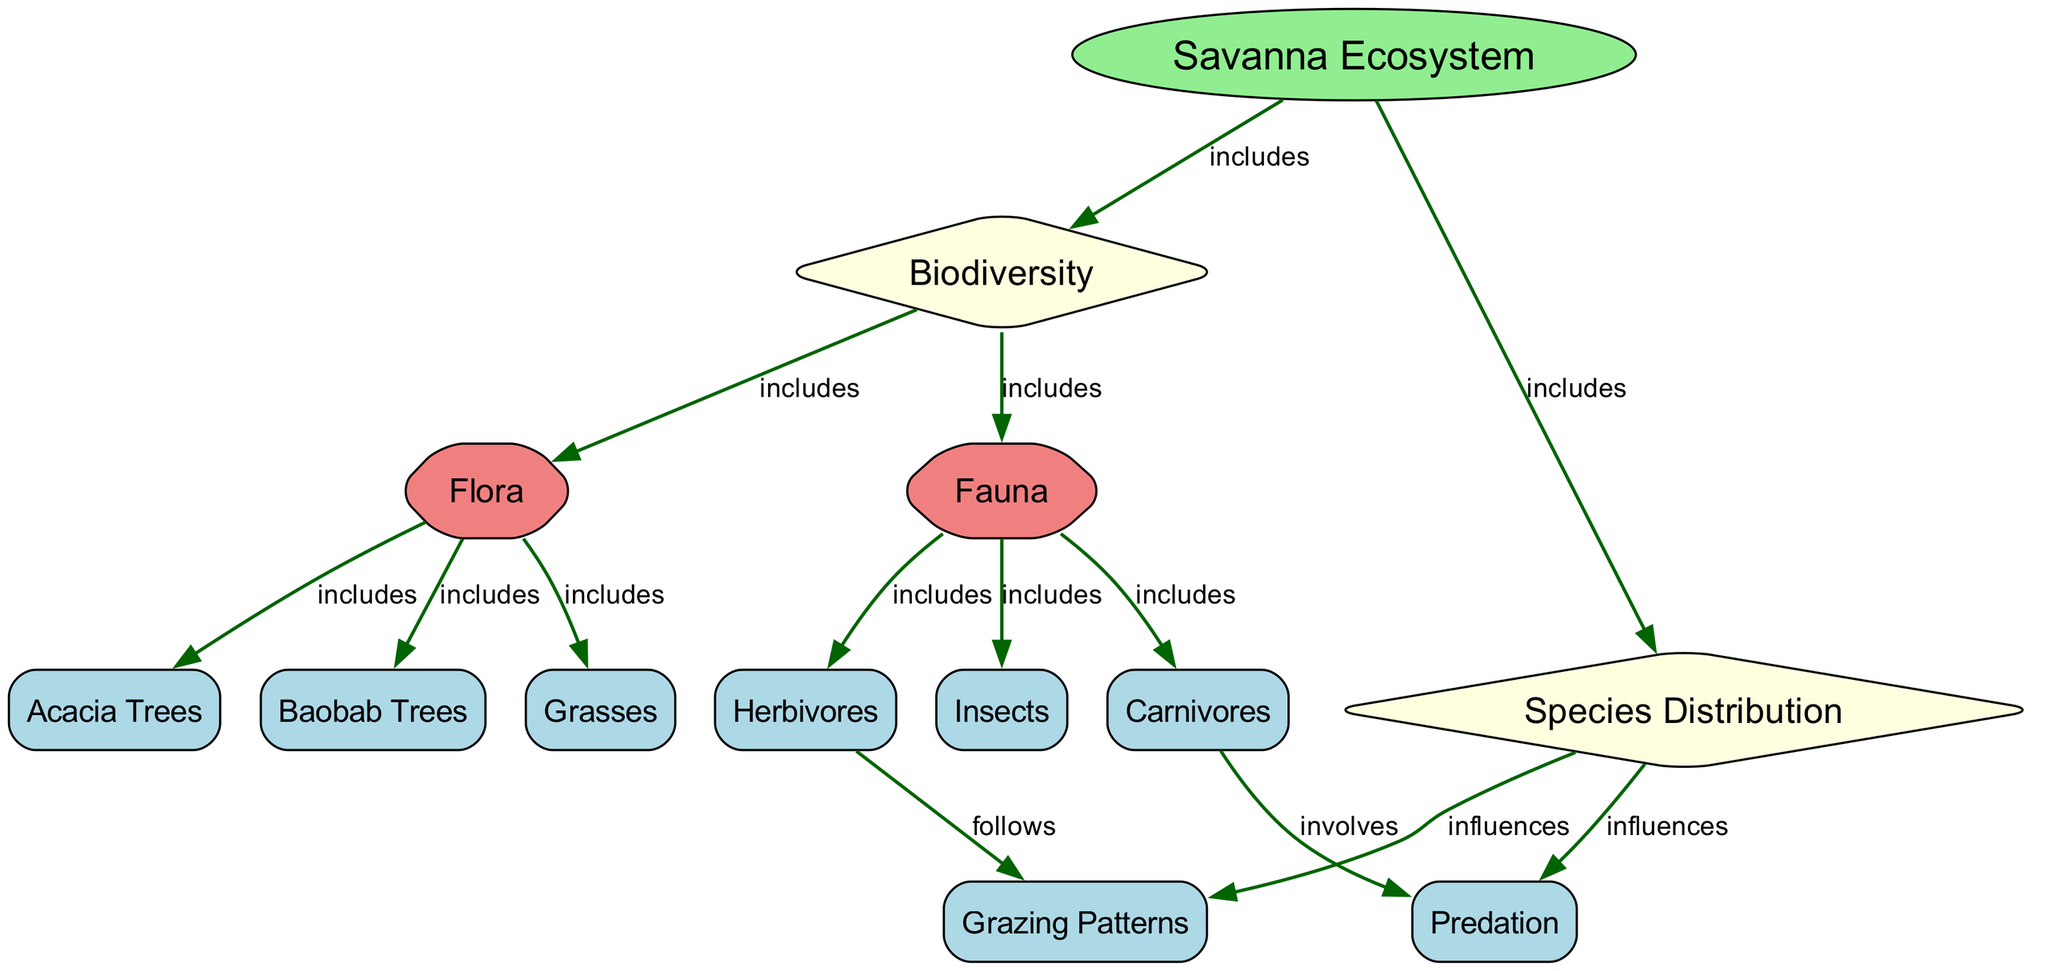What is the primary ecosystem depicted in the diagram? The diagram focuses on the "Savanna Ecosystem," which is explicitly labeled as the main subject.
Answer: Savanna Ecosystem How many nodes are present in the diagram? The diagram consists of 13 distinct nodes, each representing different aspects of the savanna ecosystem.
Answer: 13 What type of vegetation is included under flora? The diagram lists "Acacia Trees," "Baobab Trees," and "Grasses" as components of flora, showing the diversity of plant life in the savanna ecosystem.
Answer: Acacia Trees, Baobab Trees, Grasses What follows herbivores according to the diagram? The relationship indicated in the diagram shows that "Grazing Patterns" follows "Herbivores," suggesting a direct influence of herbivore activity on grazing behavior.
Answer: Grazing Patterns Which two categories are included under fauna? The diagram specifically denotes "Herbivores" and "Carnivores" as key groups associated with the fauna present in the savanna ecosystem.
Answer: Herbivores, Carnivores How does species distribution influence predation? The diagram illustrates that species distribution directly influences "Predation," indicating that the spatial arrangement of species can affect predator-prey relationships.
Answer: Influences Which elements are included under the umbrella of biodiversity? The term "Biodiversity" in the diagram encompasses both "Flora" and "Fauna," indicating that it includes all forms of life in the ecosystem.
Answer: Flora, Fauna What type of relationship exists between species distribution and grazing patterns? The diagram states that "Species Distribution" influences "Grazing Patterns," which indicates that the distribution of species determines the grazing behavior of herbivores.
Answer: Influences What role do insects play within fauna? The diagram states that "Insects" are a component included in the fauna category, indicating their importance in the ecosystem, even if no specific relationship is provided for them.
Answer: Included 